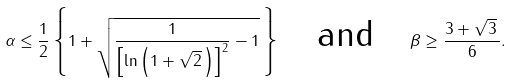Convert formula to latex. <formula><loc_0><loc_0><loc_500><loc_500>\alpha \leq \frac { 1 } { 2 } \left \{ 1 + \sqrt { \frac { 1 } { \left [ \ln \left ( 1 + \sqrt { 2 } \, \right ) \right ] ^ { 2 } } - 1 } \, \right \} \quad \text {and} \quad \beta \geq \frac { 3 + \sqrt { 3 } \, } { 6 } .</formula> 